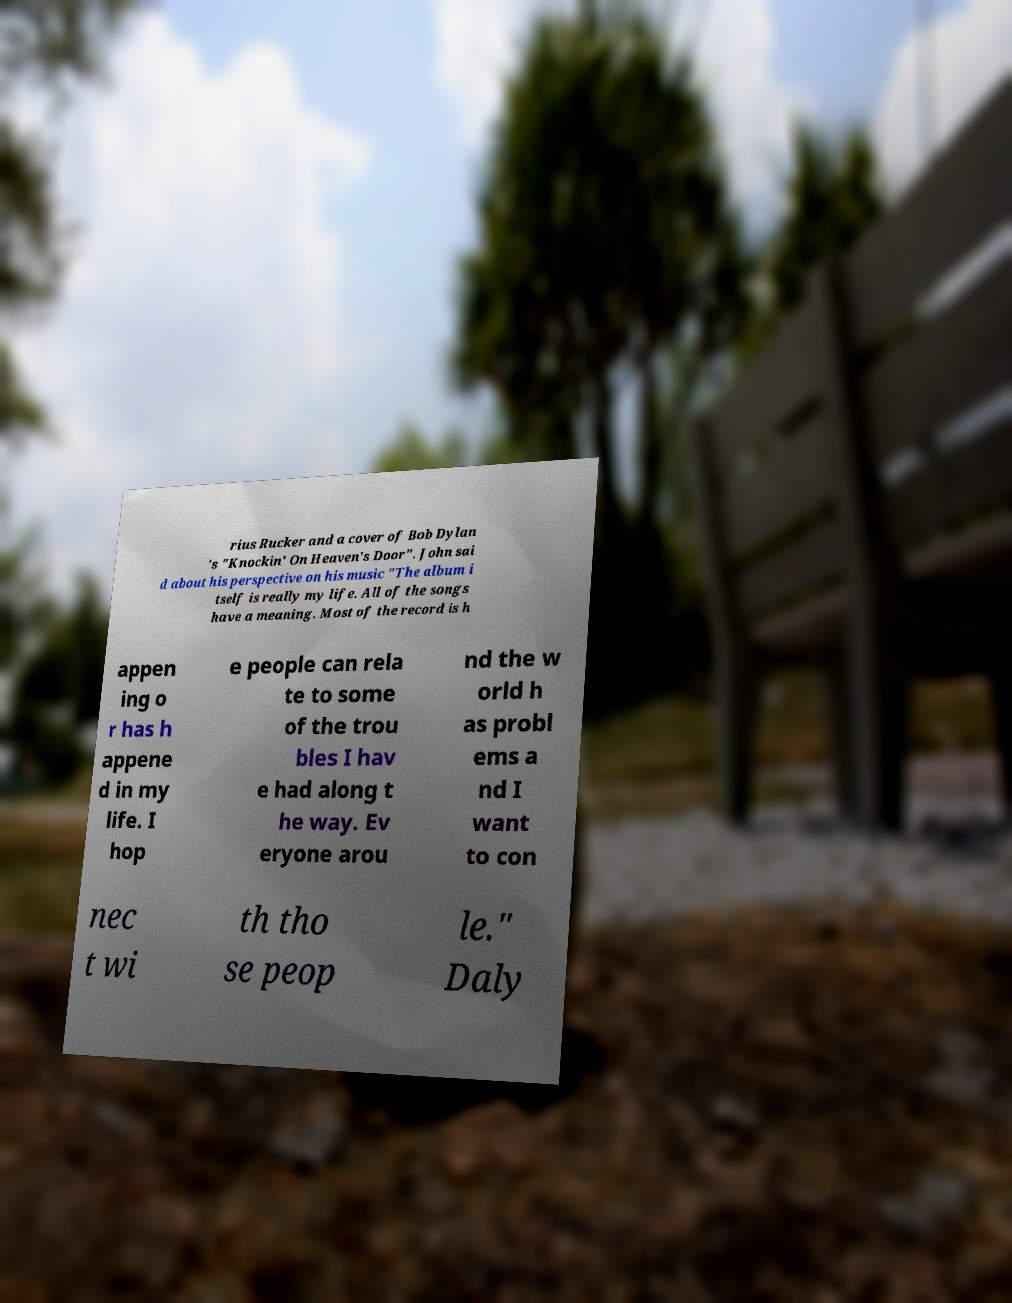Can you accurately transcribe the text from the provided image for me? rius Rucker and a cover of Bob Dylan 's "Knockin' On Heaven's Door". John sai d about his perspective on his music "The album i tself is really my life. All of the songs have a meaning. Most of the record is h appen ing o r has h appene d in my life. I hop e people can rela te to some of the trou bles I hav e had along t he way. Ev eryone arou nd the w orld h as probl ems a nd I want to con nec t wi th tho se peop le." Daly 